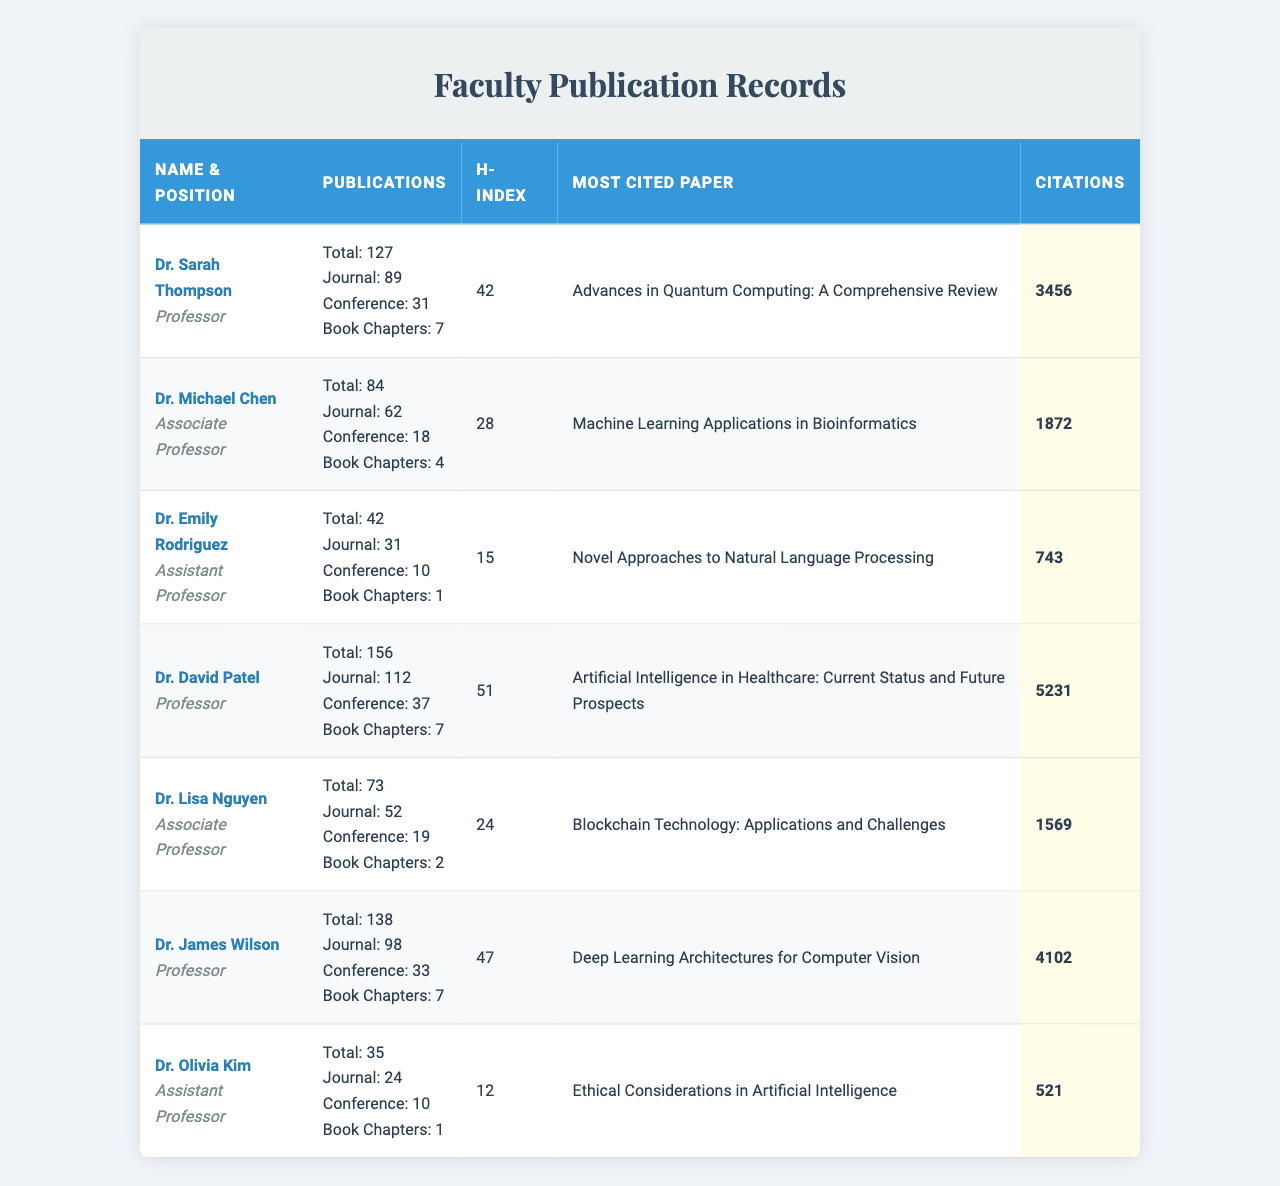What is the total number of publications for Dr. David Patel? The table lists Dr. David Patel's total publications, which shows 156 publications in total.
Answer: 156 Which faculty member has the highest h-index? By reviewing the h-index column, Dr. David Patel has an h-index of 51, which is the highest among all faculty listed.
Answer: Dr. David Patel How many journal articles has Dr. Michael Chen published? In the table, under the journal articles column for Dr. Michael Chen, the value is 62.
Answer: 62 What is the most cited paper by Dr. Sarah Thompson? The table specifies that the most cited paper by Dr. Sarah Thompson is "Advances in Quantum Computing: A Comprehensive Review."
Answer: Advances in Quantum Computing: A Comprehensive Review What is the average number of total publications for the faculty members? To find the average, sum the total publications (127 + 84 + 42 + 156 + 73 + 138 + 35 = 615) and divide by the number of faculty (7), resulting in an average of approximately 87.86.
Answer: Approximately 87.86 Does Dr. Emily Rodriguez have more conference papers than Dr. Lisa Nguyen? Dr. Emily Rodriguez has published 10 conference papers, while Dr. Lisa Nguyen has 19. Since 10 is less than 19, the answer is false.
Answer: No What is the total number of book chapters published by all faculty members? Summing the book chapters: 7 + 4 + 1 + 7 + 2 + 7 + 1 = 29, the total is 29 book chapters published by all faculty members.
Answer: 29 Which faculty member has the fewest total publications, and how many do they have? By checking the total publications for all members, Dr. Olivia Kim has the fewest with 35 publications.
Answer: Dr. Olivia Kim, 35 What percentage of Dr. James Wilson's total publications are journal articles? First, determine the number of journal articles (98) and the total publications (138). To find the percentage, use the formula (98/138) * 100, yielding approximately 71.01%.
Answer: Approximately 71.01% How many more citations does Dr. David Patel have compared to Dr. Emily Rodriguez? Dr. David Patel has 5231 citations, and Dr. Emily Rodriguez has 743. The difference is 5231 - 743 = 4488 citations more for Dr. David Patel.
Answer: 4488 